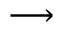Convert formula to latex. <formula><loc_0><loc_0><loc_500><loc_500>\longrightarrow</formula> 